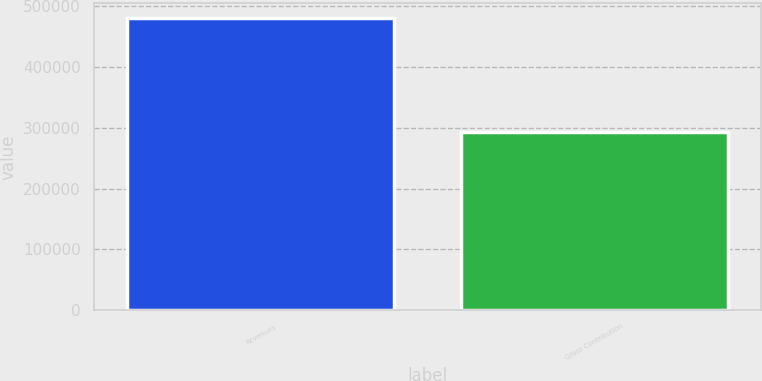Convert chart. <chart><loc_0><loc_0><loc_500><loc_500><bar_chart><fcel>Revenues<fcel>Gross Contribution<nl><fcel>480486<fcel>292704<nl></chart> 